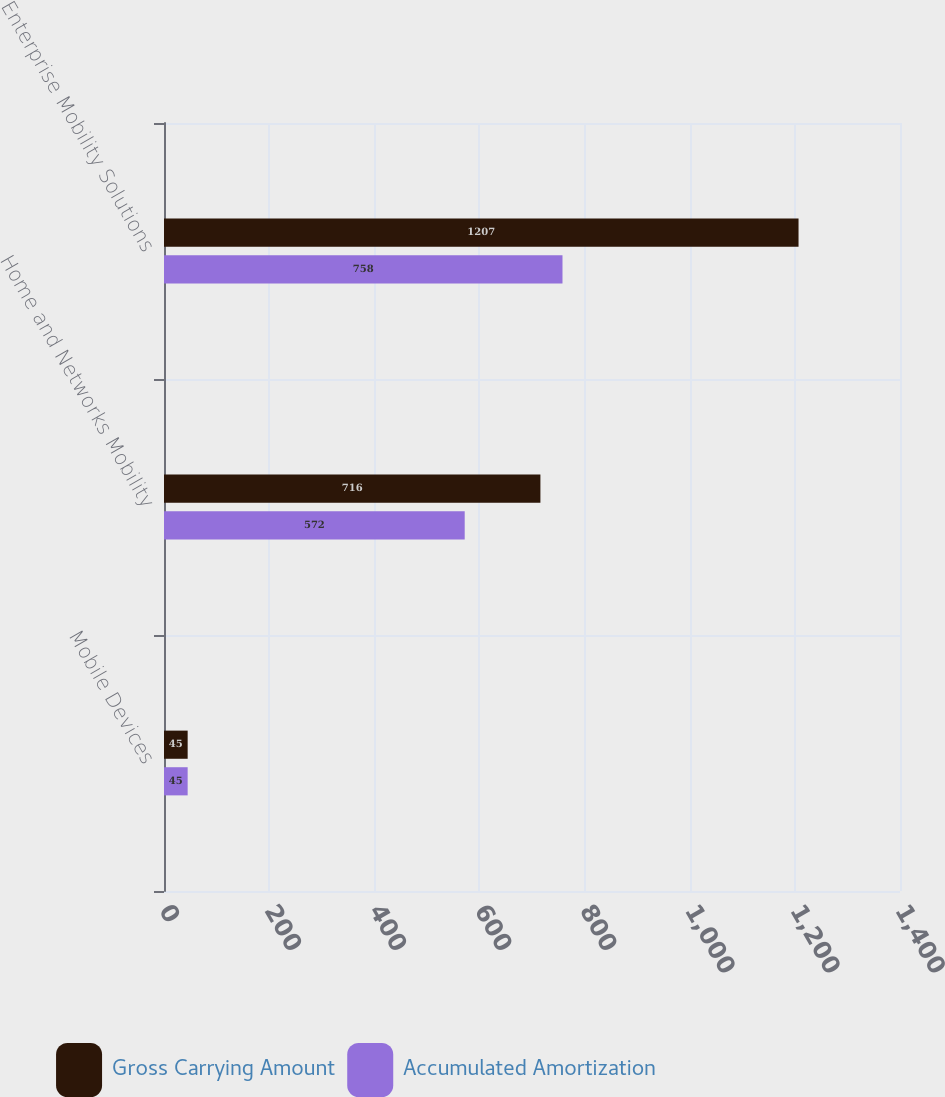<chart> <loc_0><loc_0><loc_500><loc_500><stacked_bar_chart><ecel><fcel>Mobile Devices<fcel>Home and Networks Mobility<fcel>Enterprise Mobility Solutions<nl><fcel>Gross Carrying Amount<fcel>45<fcel>716<fcel>1207<nl><fcel>Accumulated Amortization<fcel>45<fcel>572<fcel>758<nl></chart> 